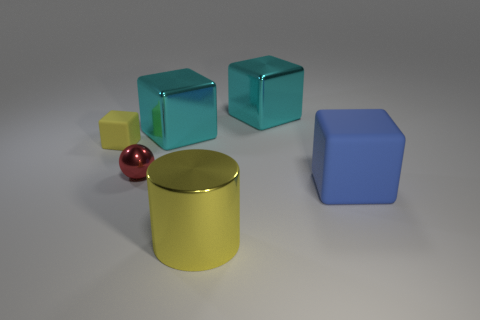Is the color of the tiny metal thing the same as the small cube?
Ensure brevity in your answer.  No. Are there any other things that have the same shape as the yellow metal thing?
Your answer should be very brief. No. What number of things are big yellow shiny cylinders that are to the right of the tiny rubber block or rubber cubes to the right of the tiny red ball?
Offer a very short reply. 2. How many other objects are there of the same color as the large cylinder?
Provide a succinct answer. 1. There is a rubber object that is to the left of the large matte block; is its shape the same as the large rubber thing?
Ensure brevity in your answer.  Yes. Is the number of metal cylinders that are behind the yellow metal cylinder less than the number of yellow cubes?
Your answer should be compact. Yes. Are there any large cyan objects made of the same material as the small red sphere?
Ensure brevity in your answer.  Yes. There is another object that is the same size as the yellow rubber thing; what is it made of?
Provide a short and direct response. Metal. Are there fewer yellow metal things that are left of the tiny yellow matte cube than big cyan metal cubes behind the large matte block?
Your answer should be very brief. Yes. There is a big thing that is both on the right side of the big yellow cylinder and behind the blue object; what shape is it?
Offer a very short reply. Cube. 